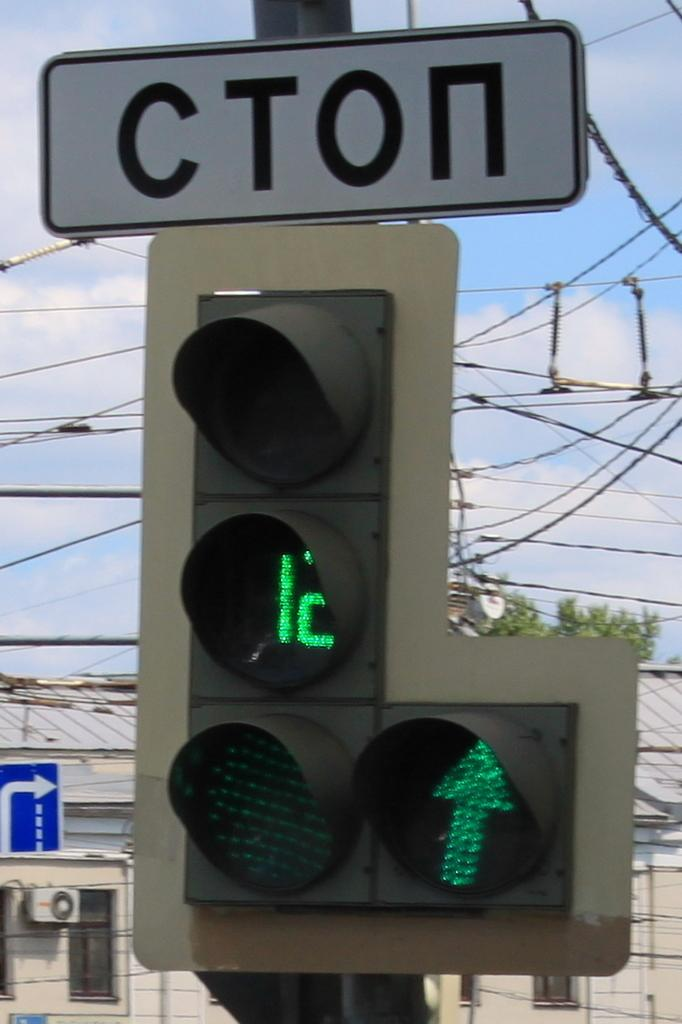<image>
Render a clear and concise summary of the photo. You have 12 seconds before the light is not green anymore. 